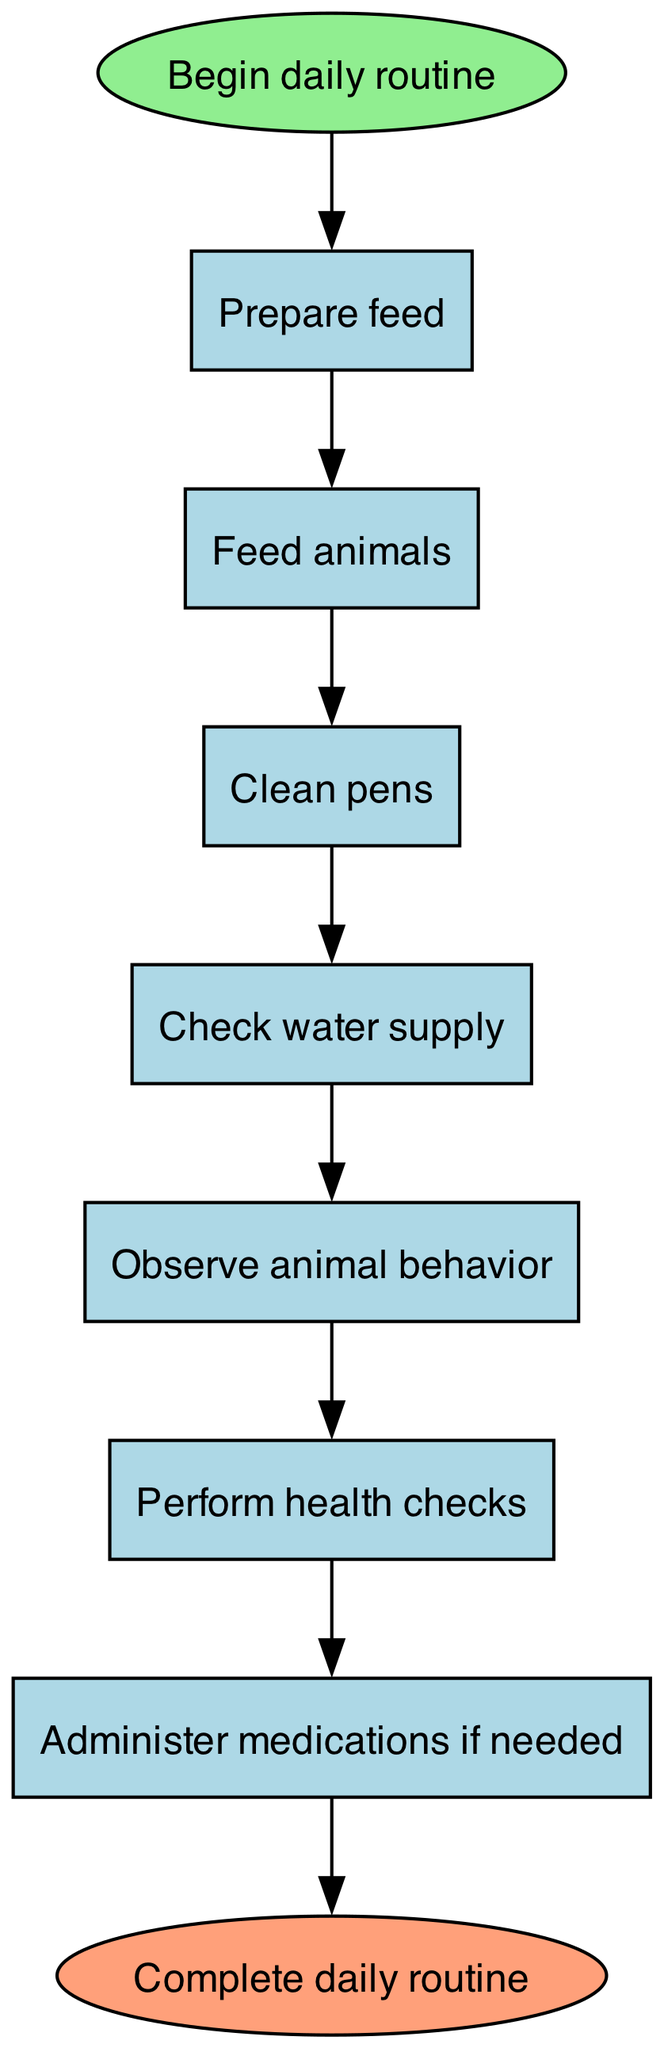What is the first step in the daily routine? The diagram indicates that the daily routine begins with the "Prepare feed" step, which is the first action taken after the "Begin daily routine" node.
Answer: Prepare feed How many steps are in the routine? By counting the individual steps listed in the diagram, there are a total of 7 steps described from "Prepare feed" to "Administer medications if needed."
Answer: 7 What step follows "Check water supply"? In the flow chart, the step that directly follows "Check water supply" is "Observe animal behavior," demonstrating a clear sequence.
Answer: Observe animal behavior Which step comes before "Record daily observations"? The step that comes before "Record daily observations" is "Administer medications if needed," shown in the flow of the diagram leading up to the final action.
Answer: Administer medications if needed What is the last step in the daily routine? According to the diagram, the final step in the daily livestock care routine is represented as "Complete daily routine," marking the end of the process after all previous steps have been completed.
Answer: Complete daily routine If an animal requires medication, which step must be taken before recording daily observations? To properly address medicinal needs, one must complete the step "Administer medications if needed" before moving on to "Record daily observations," as established in the step sequence.
Answer: Administer medications if needed How does one transition from "Feed animals" to "Clean pens"? The transition between "Feed animals" and "Clean pens" occurs through a direct edge connecting these two nodes in the diagram, indicating a sequential flow in the routine.
Answer: Clean pens What type of check is performed after observing animal behavior? Following the observation of animal behavior, the next action indicated in the diagram is to "Perform health checks," which emphasizes the importance of health monitoring in the routine.
Answer: Perform health checks 